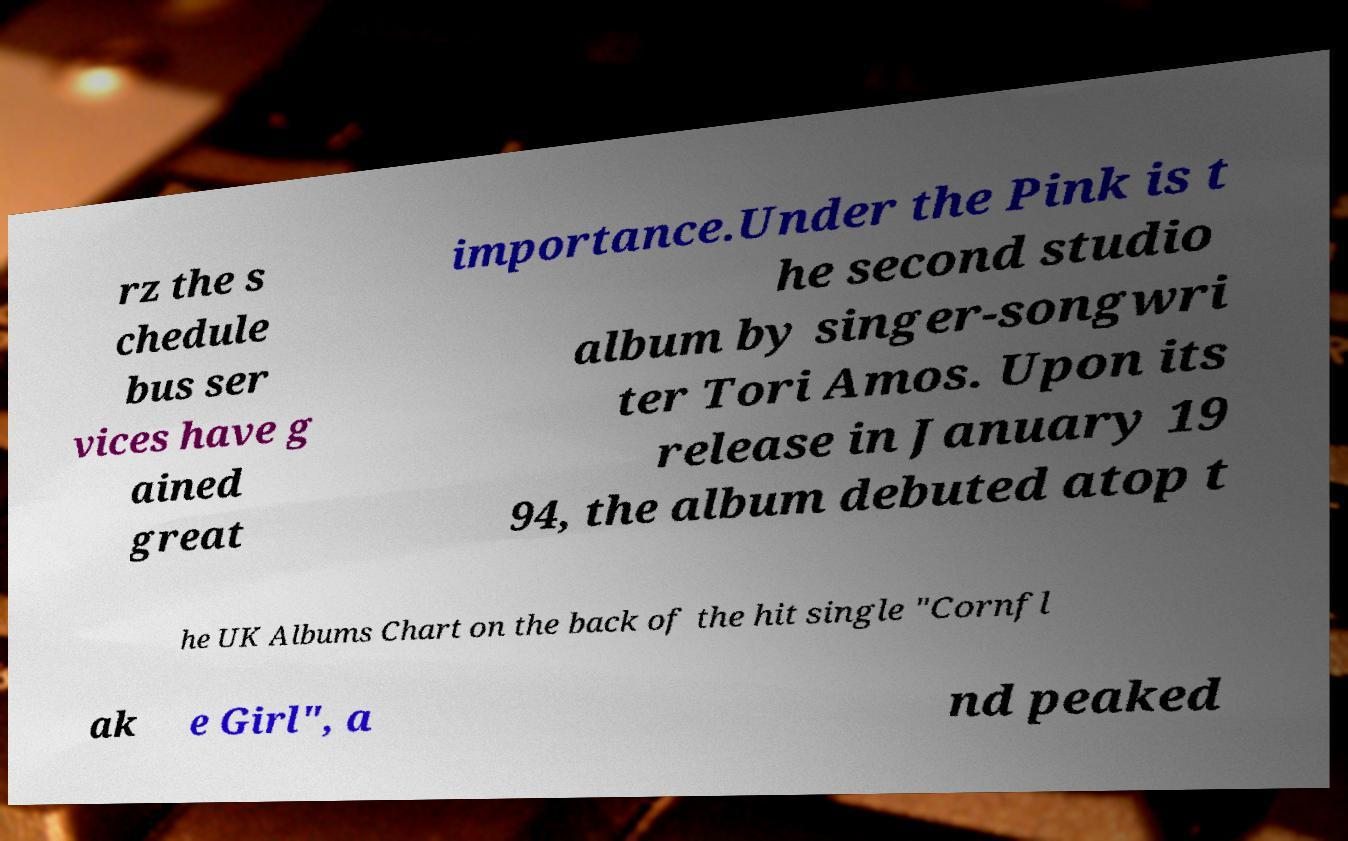For documentation purposes, I need the text within this image transcribed. Could you provide that? rz the s chedule bus ser vices have g ained great importance.Under the Pink is t he second studio album by singer-songwri ter Tori Amos. Upon its release in January 19 94, the album debuted atop t he UK Albums Chart on the back of the hit single "Cornfl ak e Girl", a nd peaked 